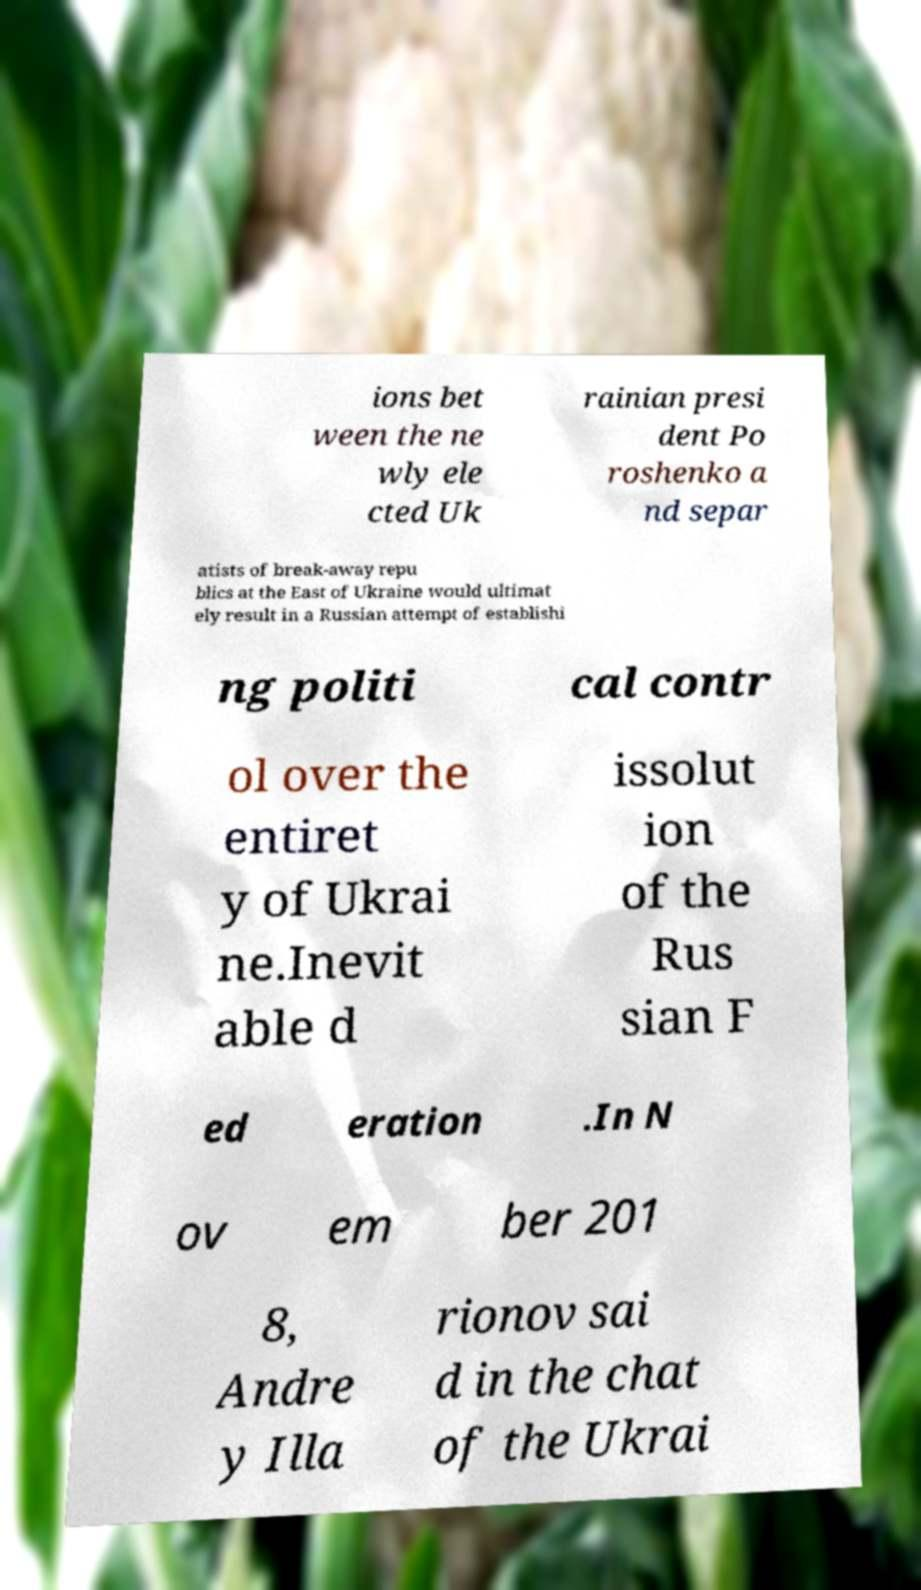Can you read and provide the text displayed in the image?This photo seems to have some interesting text. Can you extract and type it out for me? ions bet ween the ne wly ele cted Uk rainian presi dent Po roshenko a nd separ atists of break-away repu blics at the East of Ukraine would ultimat ely result in a Russian attempt of establishi ng politi cal contr ol over the entiret y of Ukrai ne.Inevit able d issolut ion of the Rus sian F ed eration .In N ov em ber 201 8, Andre y Illa rionov sai d in the chat of the Ukrai 